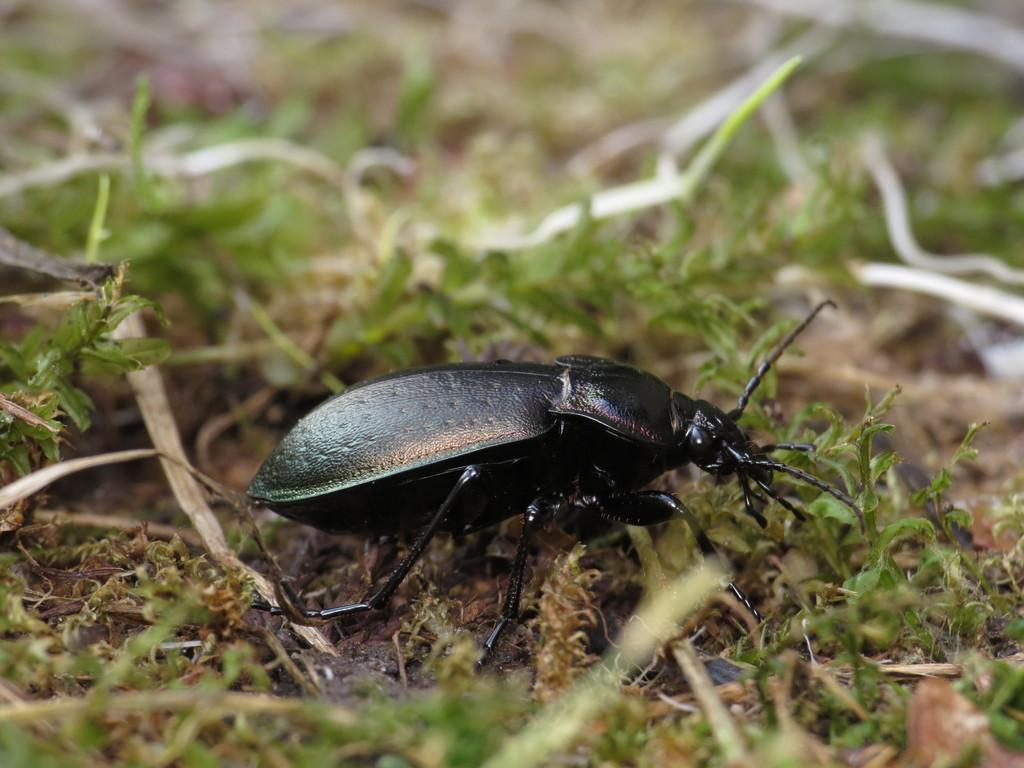What is the main subject in the middle of the image? There is an insect in the middle of the image. What else can be seen in the image besides the insect? There are plants in the image. What type of pancake is the insect eating in the image? There is no pancake present in the image, and the insect is not shown eating anything. 